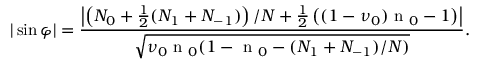Convert formula to latex. <formula><loc_0><loc_0><loc_500><loc_500>| \sin \varphi | = \frac { \left | \left ( N _ { 0 } + \frac { 1 } { 2 } ( N _ { 1 } + N _ { - 1 } ) \right ) / N + \frac { 1 } { 2 } \left ( ( 1 - \nu _ { 0 } ) n _ { 0 } - 1 \right ) \right | } { \sqrt { \nu _ { 0 } n _ { 0 } ( 1 - n _ { 0 } - ( N _ { 1 } + N _ { - 1 } ) / N ) } } .</formula> 